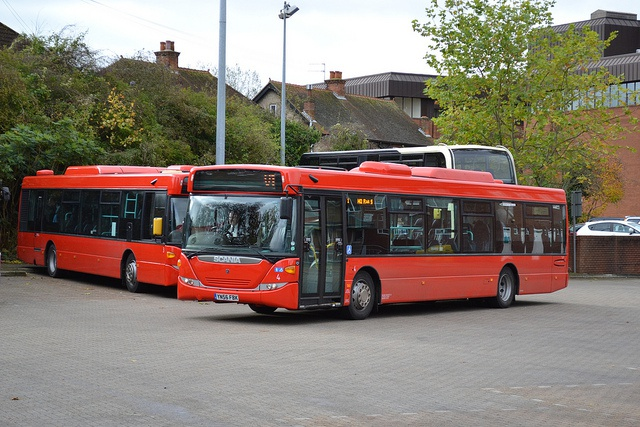Describe the objects in this image and their specific colors. I can see bus in white, black, red, gray, and brown tones, bus in white, black, red, brown, and maroon tones, bus in white, black, gray, and darkgray tones, car in white, gray, and darkgray tones, and people in white, black, gray, darkgray, and purple tones in this image. 